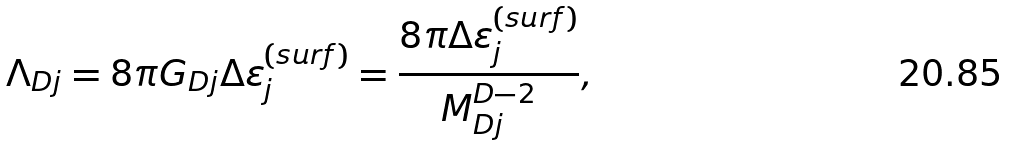Convert formula to latex. <formula><loc_0><loc_0><loc_500><loc_500>\Lambda _ { D j } = 8 \pi G _ { D j } \Delta \varepsilon ^ { ( s u r f ) } _ { j } = \frac { 8 \pi \Delta \varepsilon ^ { ( s u r f ) } _ { j } } { M ^ { D - 2 } _ { D j } } ,</formula> 